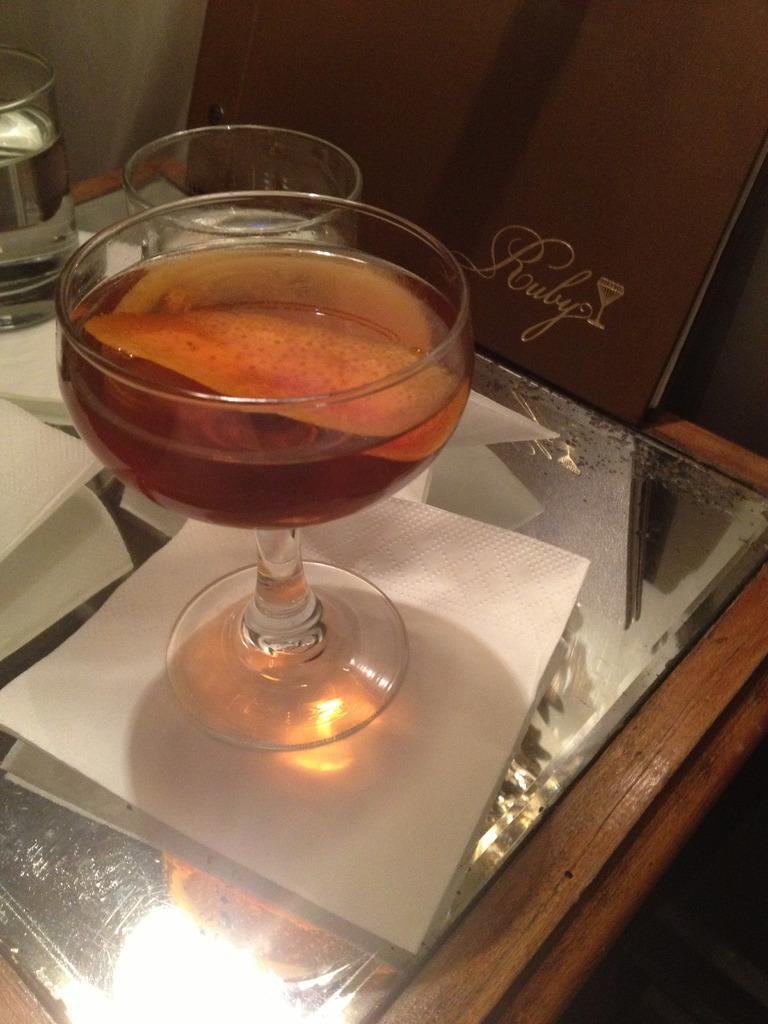How would you summarize this image in a sentence or two? It is a wooden glass table. A glass is placed on the table. This is a tissue and there is another glass at the left corner. 